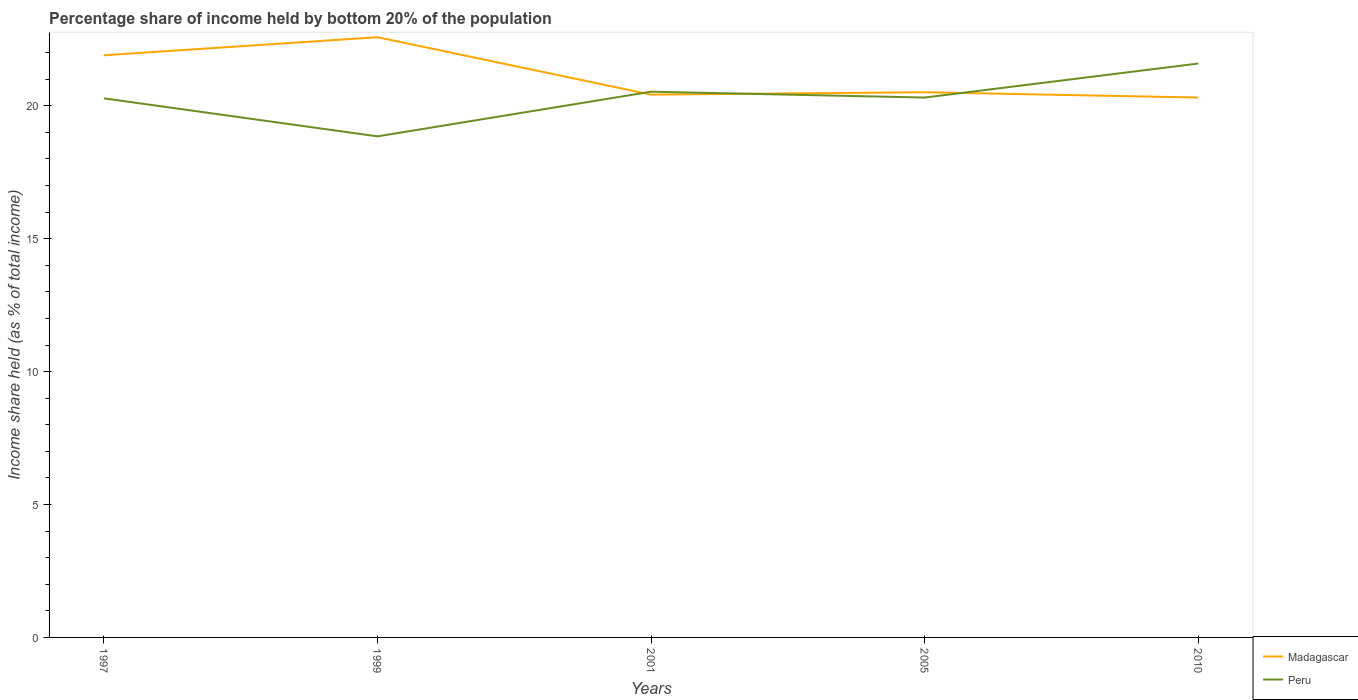How many different coloured lines are there?
Keep it short and to the point. 2. Does the line corresponding to Madagascar intersect with the line corresponding to Peru?
Offer a very short reply. Yes. Across all years, what is the maximum share of income held by bottom 20% of the population in Peru?
Your answer should be compact. 18.85. What is the total share of income held by bottom 20% of the population in Peru in the graph?
Provide a short and direct response. -1.06. What is the difference between the highest and the second highest share of income held by bottom 20% of the population in Peru?
Ensure brevity in your answer.  2.74. Is the share of income held by bottom 20% of the population in Madagascar strictly greater than the share of income held by bottom 20% of the population in Peru over the years?
Keep it short and to the point. No. How many years are there in the graph?
Your answer should be compact. 5. What is the difference between two consecutive major ticks on the Y-axis?
Provide a short and direct response. 5. Does the graph contain any zero values?
Keep it short and to the point. No. Does the graph contain grids?
Keep it short and to the point. No. How many legend labels are there?
Make the answer very short. 2. How are the legend labels stacked?
Offer a terse response. Vertical. What is the title of the graph?
Ensure brevity in your answer.  Percentage share of income held by bottom 20% of the population. Does "Mauritius" appear as one of the legend labels in the graph?
Your answer should be very brief. No. What is the label or title of the X-axis?
Give a very brief answer. Years. What is the label or title of the Y-axis?
Offer a terse response. Income share held (as % of total income). What is the Income share held (as % of total income) of Madagascar in 1997?
Your answer should be very brief. 21.9. What is the Income share held (as % of total income) of Peru in 1997?
Offer a terse response. 20.28. What is the Income share held (as % of total income) of Madagascar in 1999?
Offer a very short reply. 22.58. What is the Income share held (as % of total income) in Peru in 1999?
Keep it short and to the point. 18.85. What is the Income share held (as % of total income) in Madagascar in 2001?
Provide a succinct answer. 20.42. What is the Income share held (as % of total income) of Peru in 2001?
Make the answer very short. 20.53. What is the Income share held (as % of total income) in Madagascar in 2005?
Provide a succinct answer. 20.51. What is the Income share held (as % of total income) in Peru in 2005?
Offer a very short reply. 20.31. What is the Income share held (as % of total income) of Madagascar in 2010?
Your answer should be compact. 20.31. What is the Income share held (as % of total income) of Peru in 2010?
Provide a short and direct response. 21.59. Across all years, what is the maximum Income share held (as % of total income) in Madagascar?
Provide a succinct answer. 22.58. Across all years, what is the maximum Income share held (as % of total income) in Peru?
Offer a very short reply. 21.59. Across all years, what is the minimum Income share held (as % of total income) in Madagascar?
Offer a terse response. 20.31. Across all years, what is the minimum Income share held (as % of total income) in Peru?
Your response must be concise. 18.85. What is the total Income share held (as % of total income) of Madagascar in the graph?
Your answer should be very brief. 105.72. What is the total Income share held (as % of total income) in Peru in the graph?
Your response must be concise. 101.56. What is the difference between the Income share held (as % of total income) in Madagascar in 1997 and that in 1999?
Your answer should be compact. -0.68. What is the difference between the Income share held (as % of total income) in Peru in 1997 and that in 1999?
Keep it short and to the point. 1.43. What is the difference between the Income share held (as % of total income) in Madagascar in 1997 and that in 2001?
Your response must be concise. 1.48. What is the difference between the Income share held (as % of total income) of Madagascar in 1997 and that in 2005?
Keep it short and to the point. 1.39. What is the difference between the Income share held (as % of total income) in Peru in 1997 and that in 2005?
Give a very brief answer. -0.03. What is the difference between the Income share held (as % of total income) of Madagascar in 1997 and that in 2010?
Your answer should be very brief. 1.59. What is the difference between the Income share held (as % of total income) in Peru in 1997 and that in 2010?
Your answer should be very brief. -1.31. What is the difference between the Income share held (as % of total income) of Madagascar in 1999 and that in 2001?
Give a very brief answer. 2.16. What is the difference between the Income share held (as % of total income) in Peru in 1999 and that in 2001?
Your response must be concise. -1.68. What is the difference between the Income share held (as % of total income) in Madagascar in 1999 and that in 2005?
Offer a very short reply. 2.07. What is the difference between the Income share held (as % of total income) in Peru in 1999 and that in 2005?
Provide a succinct answer. -1.46. What is the difference between the Income share held (as % of total income) of Madagascar in 1999 and that in 2010?
Make the answer very short. 2.27. What is the difference between the Income share held (as % of total income) in Peru in 1999 and that in 2010?
Your response must be concise. -2.74. What is the difference between the Income share held (as % of total income) in Madagascar in 2001 and that in 2005?
Your answer should be compact. -0.09. What is the difference between the Income share held (as % of total income) in Peru in 2001 and that in 2005?
Provide a short and direct response. 0.22. What is the difference between the Income share held (as % of total income) in Madagascar in 2001 and that in 2010?
Ensure brevity in your answer.  0.11. What is the difference between the Income share held (as % of total income) in Peru in 2001 and that in 2010?
Make the answer very short. -1.06. What is the difference between the Income share held (as % of total income) of Madagascar in 2005 and that in 2010?
Keep it short and to the point. 0.2. What is the difference between the Income share held (as % of total income) of Peru in 2005 and that in 2010?
Make the answer very short. -1.28. What is the difference between the Income share held (as % of total income) in Madagascar in 1997 and the Income share held (as % of total income) in Peru in 1999?
Give a very brief answer. 3.05. What is the difference between the Income share held (as % of total income) in Madagascar in 1997 and the Income share held (as % of total income) in Peru in 2001?
Make the answer very short. 1.37. What is the difference between the Income share held (as % of total income) of Madagascar in 1997 and the Income share held (as % of total income) of Peru in 2005?
Provide a short and direct response. 1.59. What is the difference between the Income share held (as % of total income) in Madagascar in 1997 and the Income share held (as % of total income) in Peru in 2010?
Provide a short and direct response. 0.31. What is the difference between the Income share held (as % of total income) in Madagascar in 1999 and the Income share held (as % of total income) in Peru in 2001?
Give a very brief answer. 2.05. What is the difference between the Income share held (as % of total income) in Madagascar in 1999 and the Income share held (as % of total income) in Peru in 2005?
Provide a succinct answer. 2.27. What is the difference between the Income share held (as % of total income) in Madagascar in 1999 and the Income share held (as % of total income) in Peru in 2010?
Ensure brevity in your answer.  0.99. What is the difference between the Income share held (as % of total income) of Madagascar in 2001 and the Income share held (as % of total income) of Peru in 2005?
Offer a very short reply. 0.11. What is the difference between the Income share held (as % of total income) in Madagascar in 2001 and the Income share held (as % of total income) in Peru in 2010?
Provide a short and direct response. -1.17. What is the difference between the Income share held (as % of total income) in Madagascar in 2005 and the Income share held (as % of total income) in Peru in 2010?
Provide a short and direct response. -1.08. What is the average Income share held (as % of total income) of Madagascar per year?
Provide a short and direct response. 21.14. What is the average Income share held (as % of total income) in Peru per year?
Keep it short and to the point. 20.31. In the year 1997, what is the difference between the Income share held (as % of total income) of Madagascar and Income share held (as % of total income) of Peru?
Give a very brief answer. 1.62. In the year 1999, what is the difference between the Income share held (as % of total income) in Madagascar and Income share held (as % of total income) in Peru?
Offer a terse response. 3.73. In the year 2001, what is the difference between the Income share held (as % of total income) in Madagascar and Income share held (as % of total income) in Peru?
Give a very brief answer. -0.11. In the year 2005, what is the difference between the Income share held (as % of total income) of Madagascar and Income share held (as % of total income) of Peru?
Your response must be concise. 0.2. In the year 2010, what is the difference between the Income share held (as % of total income) of Madagascar and Income share held (as % of total income) of Peru?
Your answer should be compact. -1.28. What is the ratio of the Income share held (as % of total income) of Madagascar in 1997 to that in 1999?
Keep it short and to the point. 0.97. What is the ratio of the Income share held (as % of total income) in Peru in 1997 to that in 1999?
Provide a short and direct response. 1.08. What is the ratio of the Income share held (as % of total income) of Madagascar in 1997 to that in 2001?
Your response must be concise. 1.07. What is the ratio of the Income share held (as % of total income) in Peru in 1997 to that in 2001?
Your answer should be very brief. 0.99. What is the ratio of the Income share held (as % of total income) of Madagascar in 1997 to that in 2005?
Keep it short and to the point. 1.07. What is the ratio of the Income share held (as % of total income) in Peru in 1997 to that in 2005?
Your response must be concise. 1. What is the ratio of the Income share held (as % of total income) in Madagascar in 1997 to that in 2010?
Your answer should be very brief. 1.08. What is the ratio of the Income share held (as % of total income) in Peru in 1997 to that in 2010?
Your answer should be compact. 0.94. What is the ratio of the Income share held (as % of total income) of Madagascar in 1999 to that in 2001?
Make the answer very short. 1.11. What is the ratio of the Income share held (as % of total income) of Peru in 1999 to that in 2001?
Your answer should be compact. 0.92. What is the ratio of the Income share held (as % of total income) of Madagascar in 1999 to that in 2005?
Keep it short and to the point. 1.1. What is the ratio of the Income share held (as % of total income) of Peru in 1999 to that in 2005?
Ensure brevity in your answer.  0.93. What is the ratio of the Income share held (as % of total income) in Madagascar in 1999 to that in 2010?
Offer a terse response. 1.11. What is the ratio of the Income share held (as % of total income) of Peru in 1999 to that in 2010?
Your answer should be very brief. 0.87. What is the ratio of the Income share held (as % of total income) in Peru in 2001 to that in 2005?
Make the answer very short. 1.01. What is the ratio of the Income share held (as % of total income) in Madagascar in 2001 to that in 2010?
Ensure brevity in your answer.  1.01. What is the ratio of the Income share held (as % of total income) of Peru in 2001 to that in 2010?
Your response must be concise. 0.95. What is the ratio of the Income share held (as % of total income) in Madagascar in 2005 to that in 2010?
Provide a short and direct response. 1.01. What is the ratio of the Income share held (as % of total income) of Peru in 2005 to that in 2010?
Give a very brief answer. 0.94. What is the difference between the highest and the second highest Income share held (as % of total income) of Madagascar?
Provide a short and direct response. 0.68. What is the difference between the highest and the second highest Income share held (as % of total income) of Peru?
Ensure brevity in your answer.  1.06. What is the difference between the highest and the lowest Income share held (as % of total income) in Madagascar?
Your answer should be compact. 2.27. What is the difference between the highest and the lowest Income share held (as % of total income) in Peru?
Your response must be concise. 2.74. 